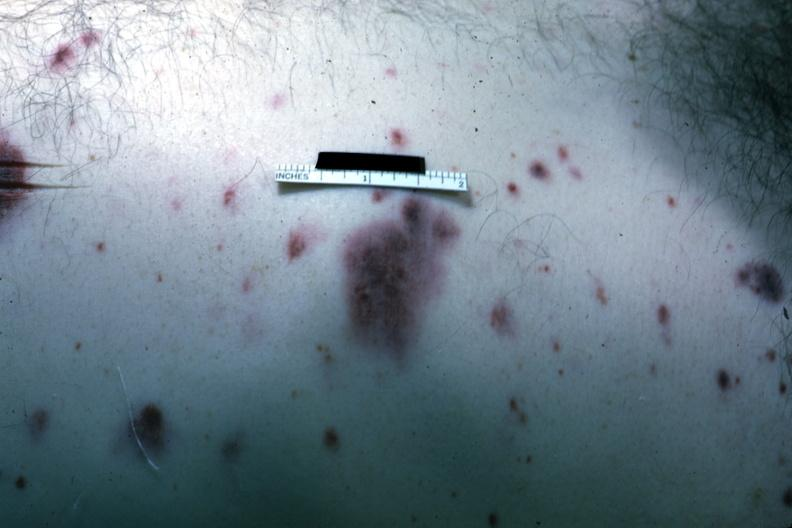how does this image show rather close-up view of typical skin hemorrhages case of acute myelogenous leukemia?
Answer the question using a single word or phrase. With terminal candida infection 